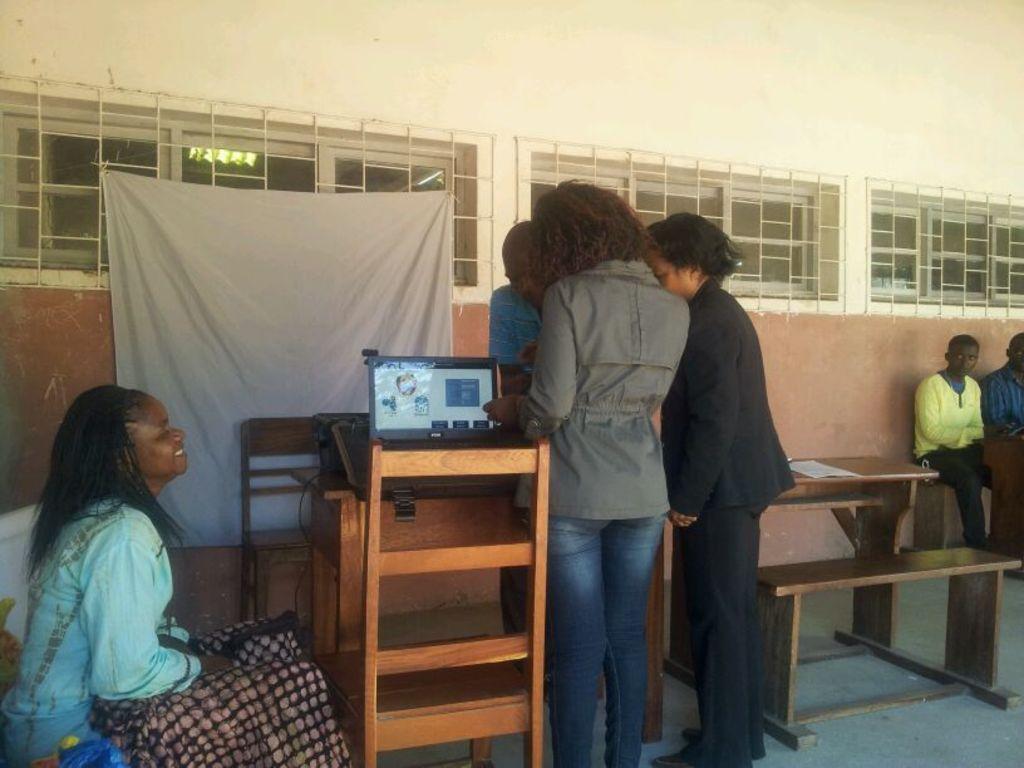In one or two sentences, can you explain what this image depicts? Here in this picture we can see a group of people standing on the floor over there and in front of them we can see a table, on which we can see a laptop present and we can also see chairs over there and beside them on the right side we can see a table and a bench present and we can see other people siting over a place and smiling and in the middle we can see a cloth present on the wall over there and we can see window present all over there. 